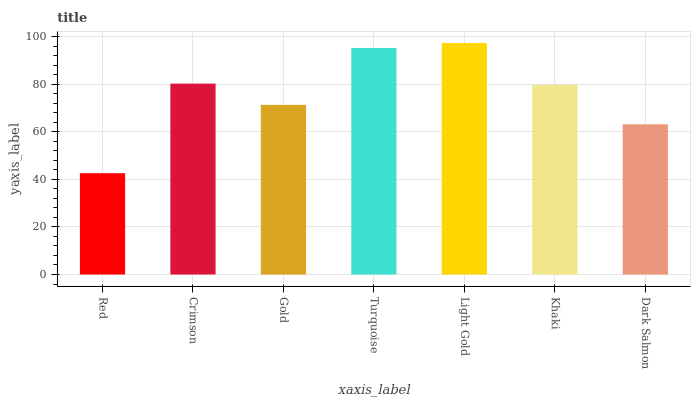Is Red the minimum?
Answer yes or no. Yes. Is Light Gold the maximum?
Answer yes or no. Yes. Is Crimson the minimum?
Answer yes or no. No. Is Crimson the maximum?
Answer yes or no. No. Is Crimson greater than Red?
Answer yes or no. Yes. Is Red less than Crimson?
Answer yes or no. Yes. Is Red greater than Crimson?
Answer yes or no. No. Is Crimson less than Red?
Answer yes or no. No. Is Khaki the high median?
Answer yes or no. Yes. Is Khaki the low median?
Answer yes or no. Yes. Is Crimson the high median?
Answer yes or no. No. Is Gold the low median?
Answer yes or no. No. 